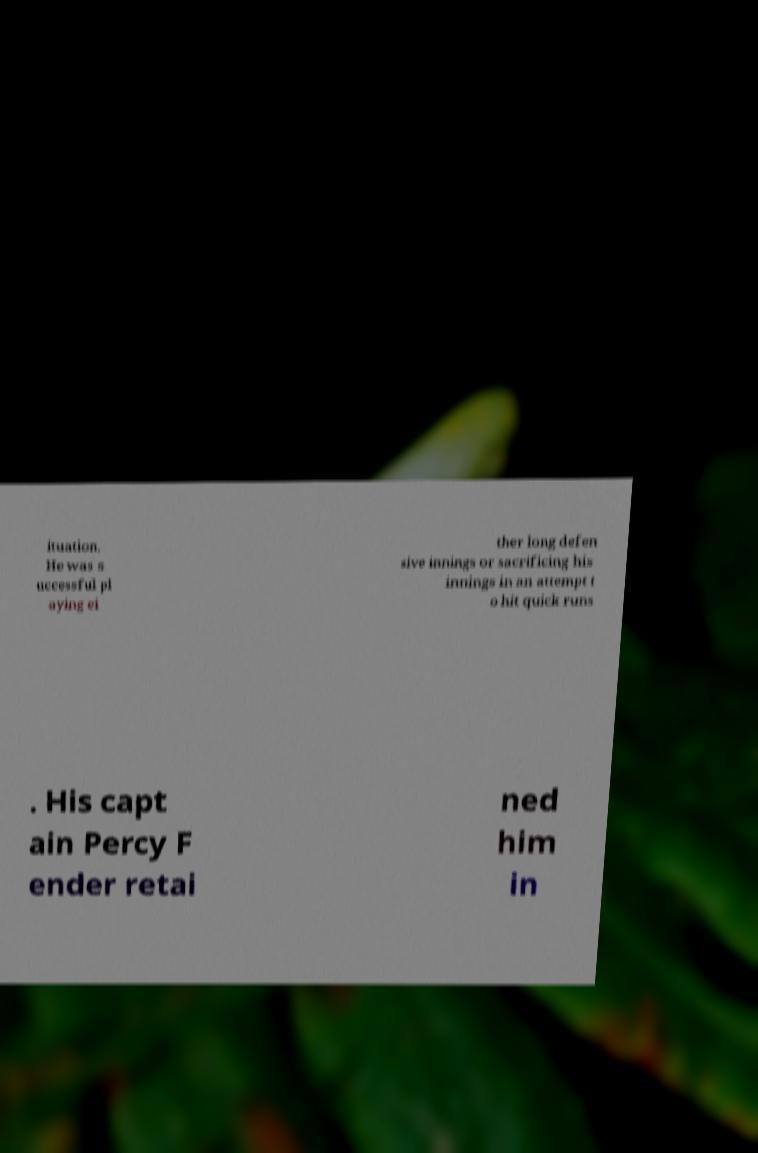Please identify and transcribe the text found in this image. ituation. He was s uccessful pl aying ei ther long defen sive innings or sacrificing his innings in an attempt t o hit quick runs . His capt ain Percy F ender retai ned him in 